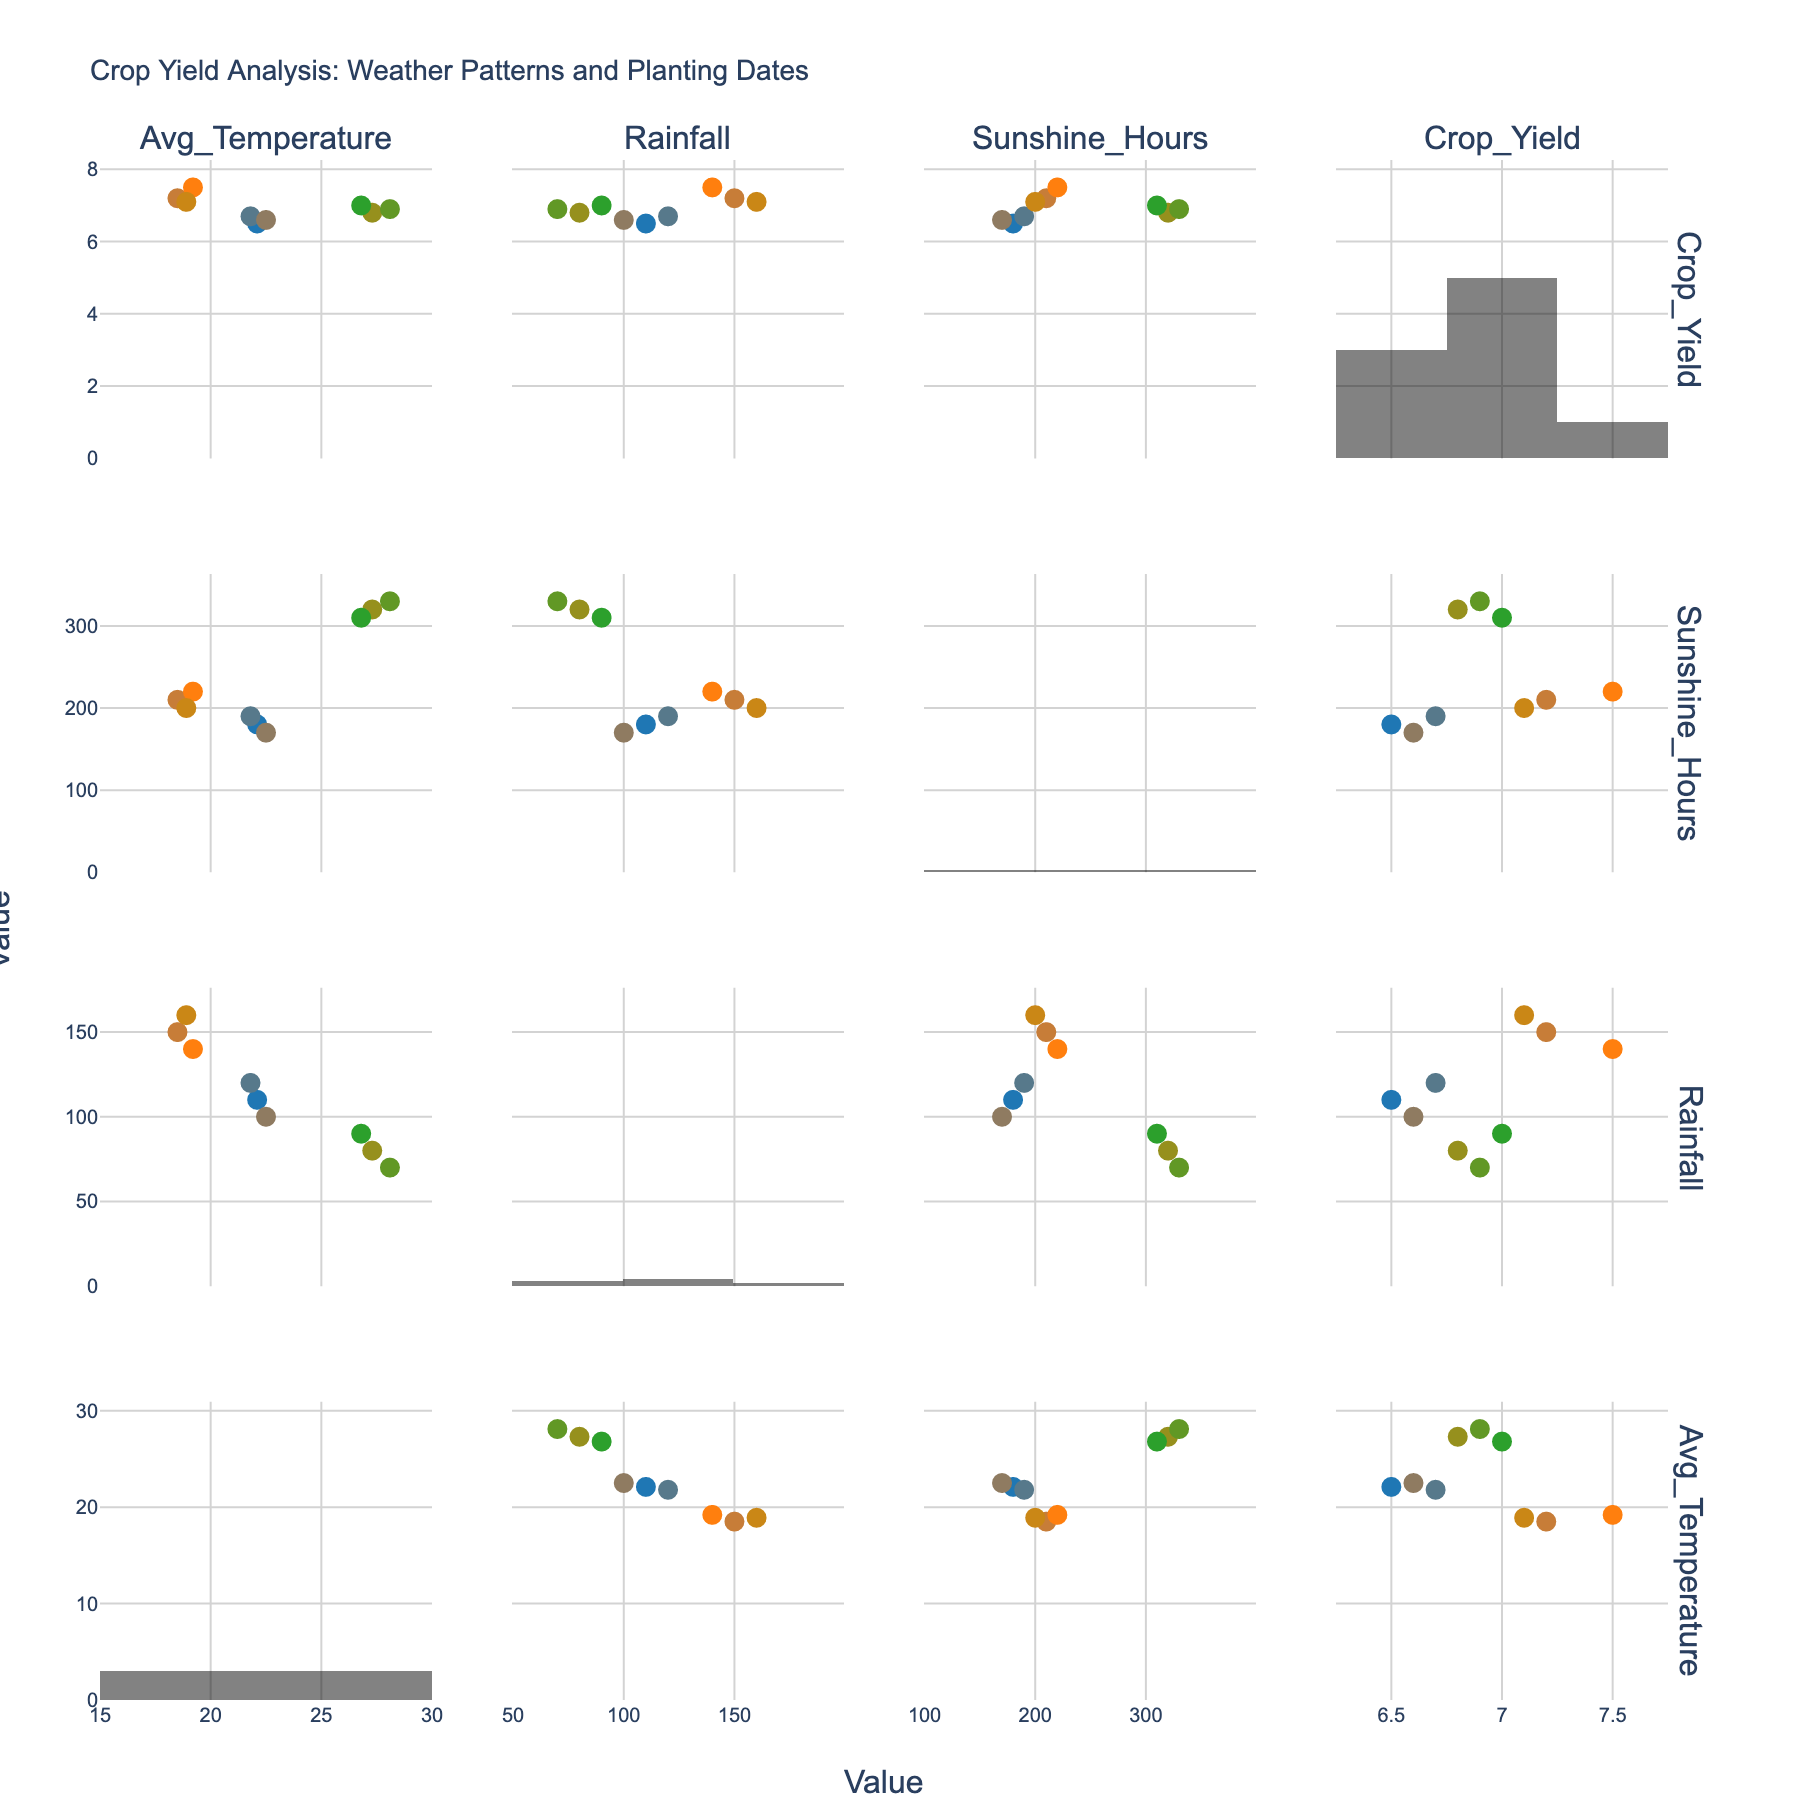What is the title of the figure? The title of the figure is usually located at the top and provides a summary of what the figure illustrates. Here, it reads "Daily Revenue Breakdown by Resort Amenities".
Answer: Daily Revenue Breakdown by Resort Amenities Which amenity generates the highest daily revenue? By looking at the bar chart in the "Top 5 Revenue Generators" subplot, the tallest bar represents the amenity that generates the highest daily revenue. This amenity is "Oceanfront Rooms" with $8500.
Answer: Oceanfront Rooms What is the daily revenue of the Beachside Cabanas? By checking the label on the bar corresponding to "Beachside Cabanas" in the "Top 5 Revenue Generators" subplot, the daily revenue is displayed as $3200.
Answer: $3200 How does the daily revenue of the Spa Services compare to the daily revenue of the Beach Bar? By comparing the heights of the bars for "Spa Services" and "Beach Bar" in the "Top 5 Revenue Generators" subplot, it's clear that "Spa Services" have a daily revenue of $2500, while "Beach Bar" has $3000. Thus, "Beach Bar" generates more daily revenue than "Spa Services".
Answer: Beach Bar generates more What is the combined daily revenue of all the top 5 revenue-generating amenities? Sum the daily revenues of the top 5 amenities: Oceanfront Rooms ($8500), Beachside Cabanas ($3200), Surf Lessons ($1800), Spa Services ($2500), and Seafood Restaurant ($4200). The calculation is: 8500 + 3200 + 1800 + 2500 + 4200 = 20,200.
Answer: $20,200 Which subplot shows the "Gift Shop" revenue, and what is it? By checking both subplots, "Gift Shop" is found in the "Other Amenities" subplot with a daily revenue of $1200.
Answer: Other Amenities, $1200 What is the average daily revenue of the amenities in the "Other Amenities" subplot? To find the average, sum the daily revenues of the 5 amenities in "Other Amenities": Water Sports Equipment Rental ($1500), Sunset Cruises ($2000), Yoga Classes ($800), Gift Shop ($1200), and Beach Bar ($3000). The calculation is: (1500 + 2000 + 800 + 1200 + 3000) / 5 = 8500 / 5 = 1700.
Answer: $1700 What is the color used for the bars in the "Top 5 Revenue Generators" plot? Observing the "Top 5 Revenue Generators" subplot, the bars are colored in green.
Answer: Green Which amenity in the "Other Amenities" subplot has the lowest daily revenue, and what is the value? By identifying the shortest bar in the "Other Amenities" subplot, "Yoga Classes" has the lowest daily revenue with $800.
Answer: Yoga Classes, $800 